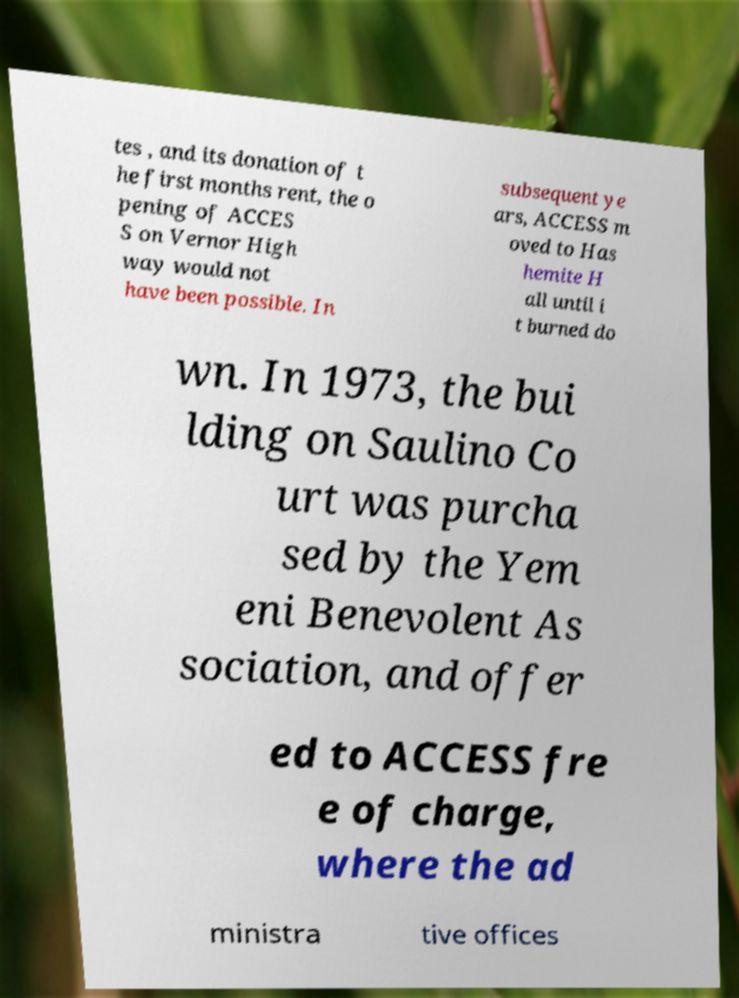Could you assist in decoding the text presented in this image and type it out clearly? tes , and its donation of t he first months rent, the o pening of ACCES S on Vernor High way would not have been possible. In subsequent ye ars, ACCESS m oved to Has hemite H all until i t burned do wn. In 1973, the bui lding on Saulino Co urt was purcha sed by the Yem eni Benevolent As sociation, and offer ed to ACCESS fre e of charge, where the ad ministra tive offices 